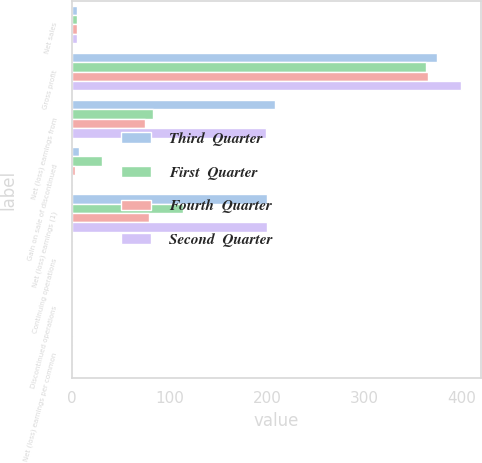Convert chart. <chart><loc_0><loc_0><loc_500><loc_500><stacked_bar_chart><ecel><fcel>Net sales<fcel>Gross profit<fcel>Net (loss) earnings from<fcel>Gain on sale of discontinued<fcel>Net (loss) earnings (1)<fcel>Continuing operations<fcel>Discontinued operations<fcel>Net (loss) earnings per common<nl><fcel>Third  Quarter<fcel>5.4<fcel>374<fcel>208<fcel>7.4<fcel>200.6<fcel>1.25<fcel>0.04<fcel>1.21<nl><fcel>First  Quarter<fcel>5.4<fcel>363.5<fcel>83.3<fcel>31.1<fcel>114.4<fcel>0.52<fcel>0.19<fcel>0.71<nl><fcel>Fourth  Quarter<fcel>5.4<fcel>365.5<fcel>75.6<fcel>3.4<fcel>79<fcel>0.48<fcel>0.02<fcel>0.5<nl><fcel>Second  Quarter<fcel>5.4<fcel>399.1<fcel>199.4<fcel>0.9<fcel>200.3<fcel>1.28<fcel>0.01<fcel>1.29<nl></chart> 